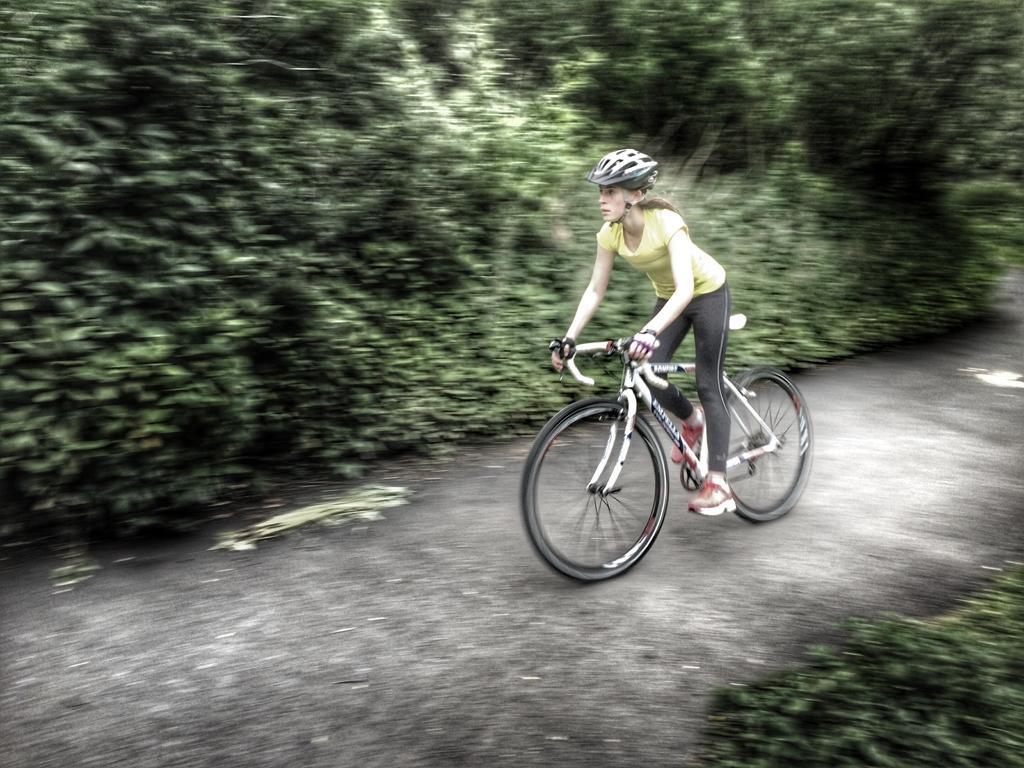Could you give a brief overview of what you see in this image? In this image we can see the women wearing yellow color T-shirt, helmet and shoes is riding the bicycle on the road. The background of the image is slightly blurred, where we can see the trees. 